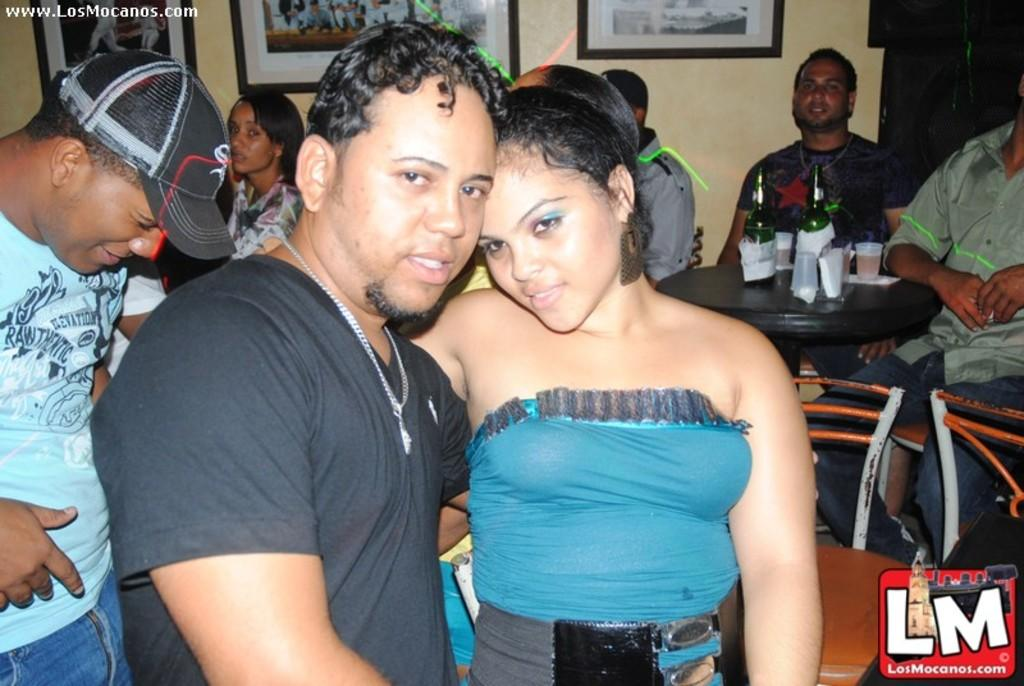What is the man on the left side of the image wearing? The man on the left side of the image is wearing a cap. What can be seen in the middle of the image? There is a man and a girl standing together in the middle of the image. What is on the table on the right side of the image? There are wine bottles on a table on the right side of the image. What type of soup is being served in the image? There is no soup present in the image. How does the man on the left side of the image get into trouble in the image? The man on the left side of the image does not get into trouble in the image; he is simply wearing a cap. 